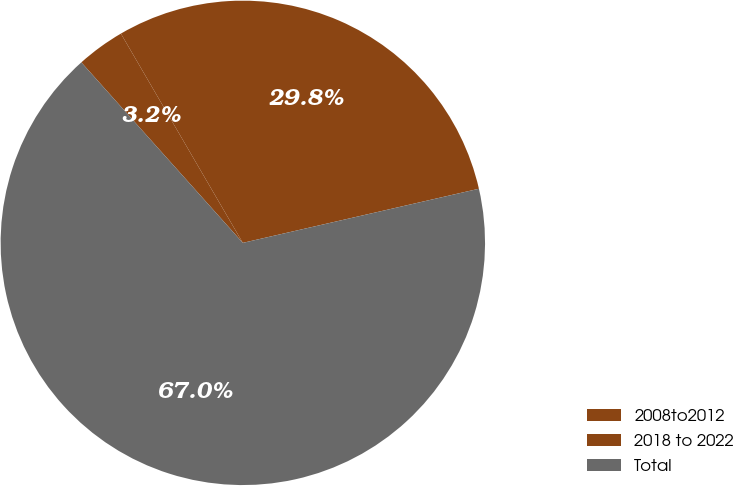<chart> <loc_0><loc_0><loc_500><loc_500><pie_chart><fcel>2008to2012<fcel>2018 to 2022<fcel>Total<nl><fcel>3.22%<fcel>29.81%<fcel>66.97%<nl></chart> 